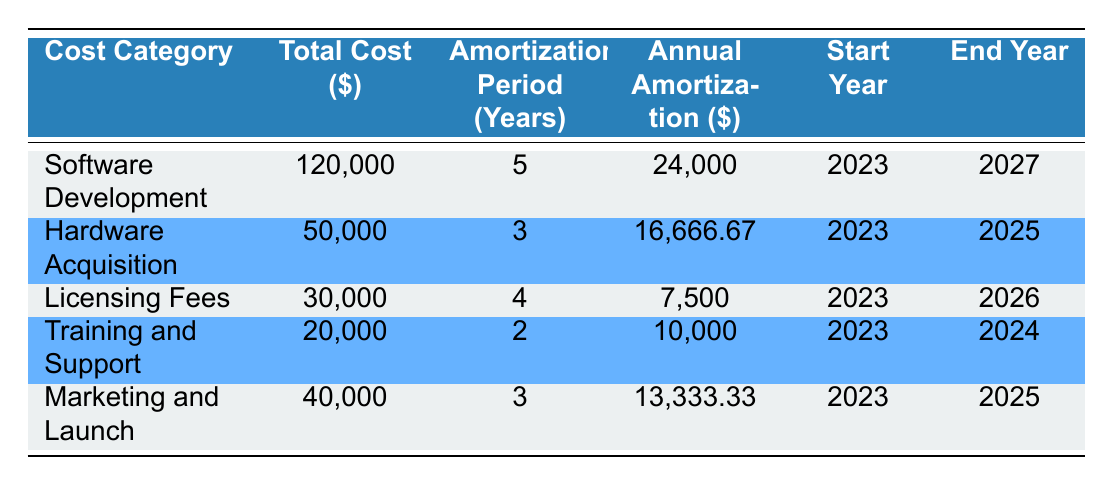What is the total cost for Software Development? The table lists the total cost for Software Development as $120,000.
Answer: 120000 Which cost category has the longest amortization period? By comparing the amortization periods across all categories, Software Development has the longest period of 5 years.
Answer: Software Development What is the annual amortization for Licensing Fees? The table specifies the annual amortization for Licensing Fees as $7,500.
Answer: 7500 Do Training and Support costs amortize over more than 2 years? The amortization period for Training and Support is 2 years, which is not more than 2 years. Therefore, the answer is no.
Answer: No What is the total annual amortization across all cost categories? To find the total annual amortization, sum the values: 24,000 + 16,666.67 + 7,500 + 10,000 + 13,333.33 = 71,500.
Answer: 71500 Which cost categories are scheduled to end in 2025? By checking each row, the cost categories with end years of 2025 are Hardware Acquisition and Marketing and Launch.
Answer: Hardware Acquisition, Marketing and Launch Is the total cost for Hardware Acquisition higher than $60,000? The total cost for Hardware Acquisition is $50,000, which is not higher than $60,000. Therefore, the answer is no.
Answer: No What is the average annual amortization among all categories? To find the average, first sum all annual amortization values (24,000 + 16,666.67 + 7,500 + 10,000 + 13,333.33 = 71,500). Then divide by the number of categories (5). Thus, the average is 71,500 / 5 = 14,300.
Answer: 14300 What is the difference in total costs between Software Development and Training and Support? The total cost for Software Development is $120,000 and for Training and Support is $20,000. The difference is 120,000 - 20,000 = 100,000.
Answer: 100000 